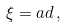Convert formula to latex. <formula><loc_0><loc_0><loc_500><loc_500>\xi = a d \, ,</formula> 